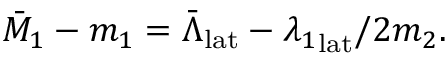<formula> <loc_0><loc_0><loc_500><loc_500>\bar { M } _ { 1 } - m _ { 1 } = \bar { \Lambda } _ { l a t } - { \lambda _ { 1 } } _ { l a t } / 2 m _ { 2 } .</formula> 